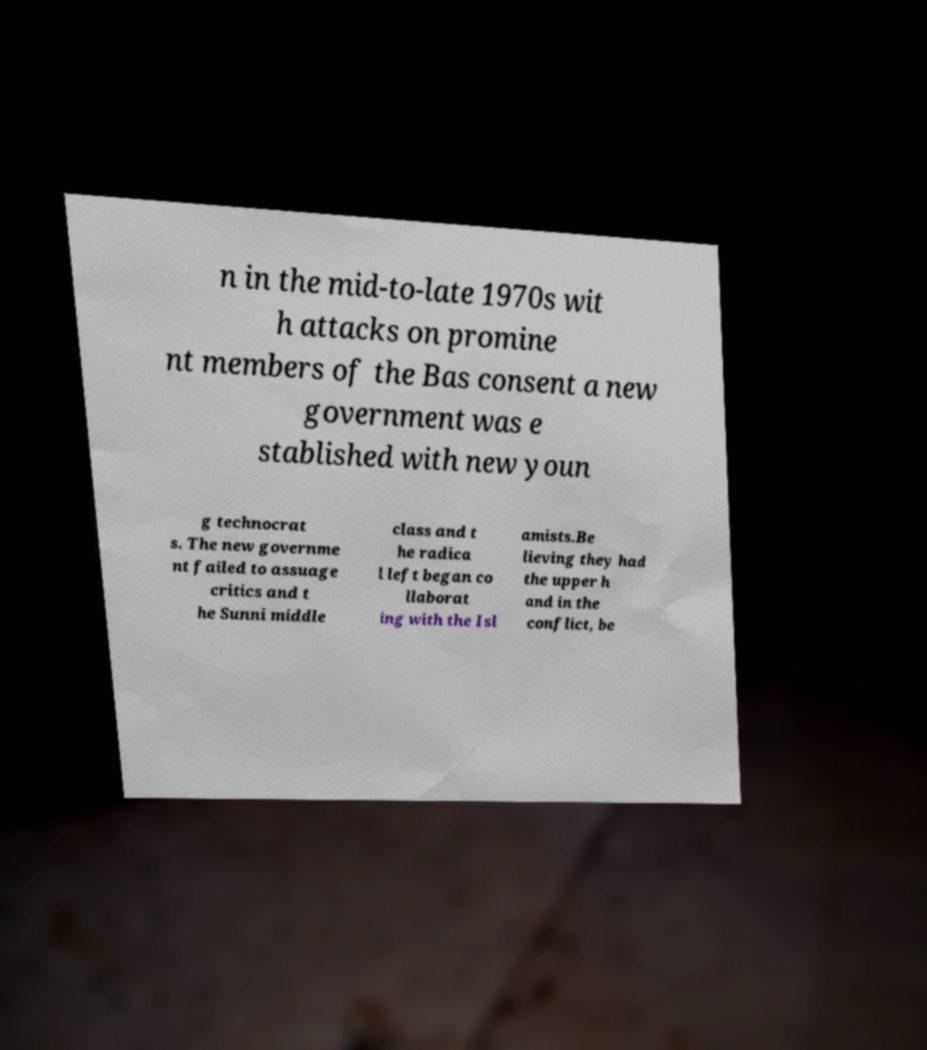Can you accurately transcribe the text from the provided image for me? n in the mid-to-late 1970s wit h attacks on promine nt members of the Bas consent a new government was e stablished with new youn g technocrat s. The new governme nt failed to assuage critics and t he Sunni middle class and t he radica l left began co llaborat ing with the Isl amists.Be lieving they had the upper h and in the conflict, be 